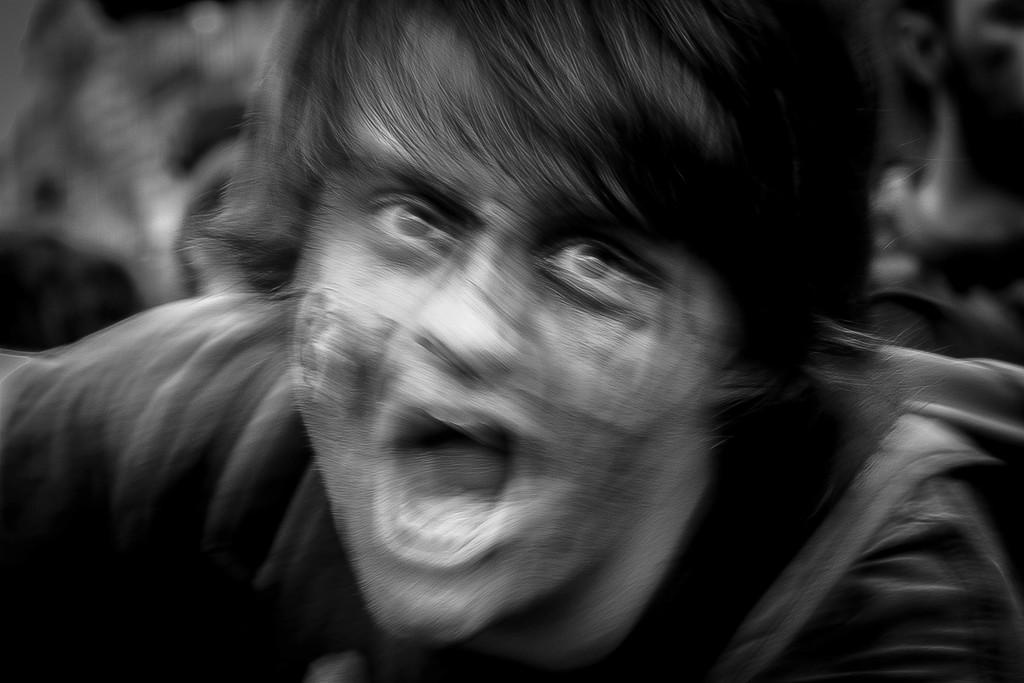Who or what is the main subject in the image? There is a person in the image. Can you describe the background of the image? The background of the image is blurry. What type of doll is sitting on the person's nose in the image? There is no doll present in the image, nor is there any indication of a doll sitting on the person's nose. 